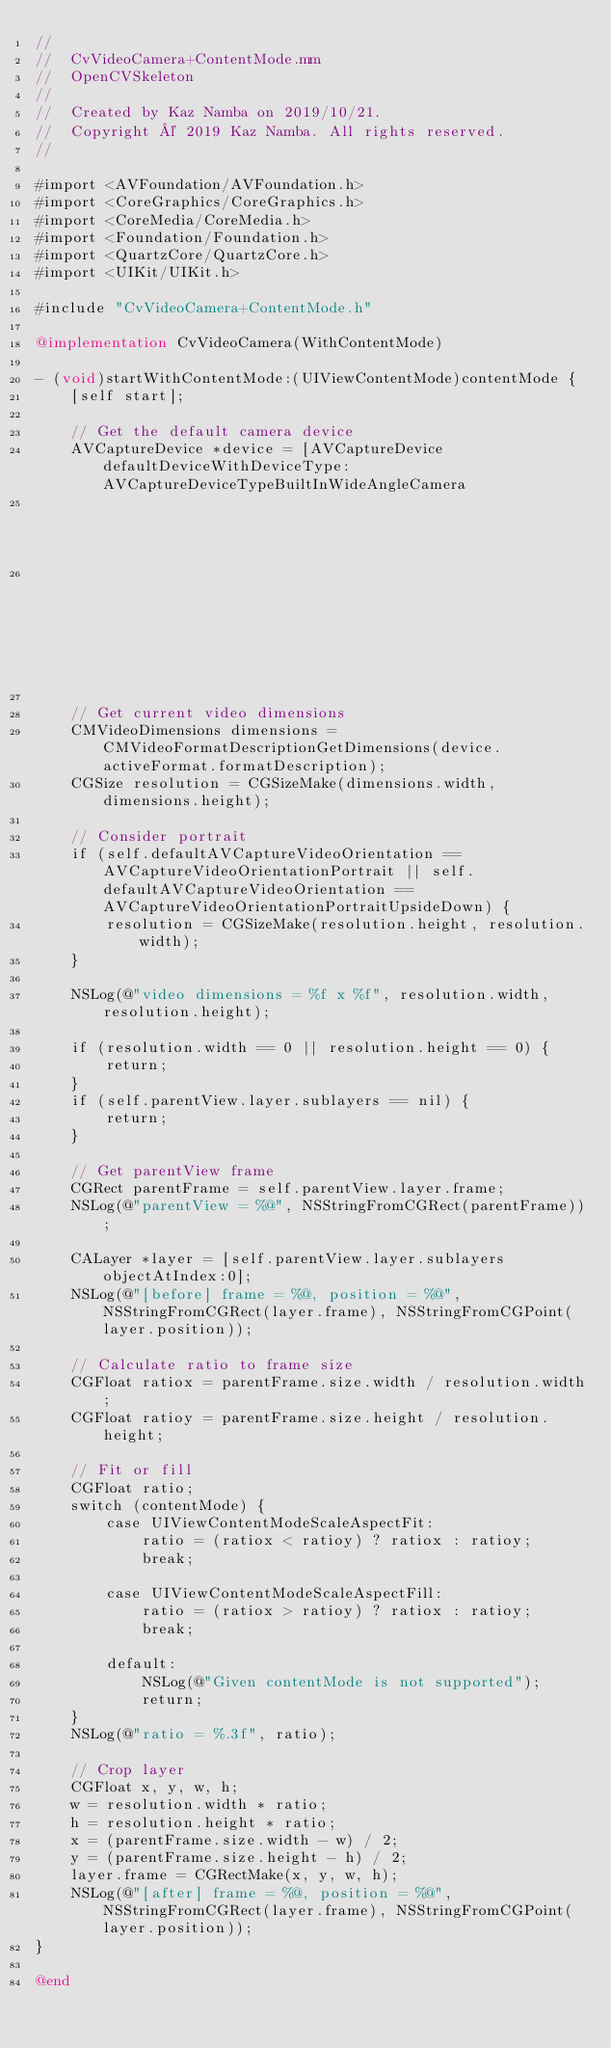<code> <loc_0><loc_0><loc_500><loc_500><_ObjectiveC_>//
//  CvVideoCamera+ContentMode.mm
//  OpenCVSkeleton
//
//  Created by Kaz Namba on 2019/10/21.
//  Copyright © 2019 Kaz Namba. All rights reserved.
//

#import <AVFoundation/AVFoundation.h>
#import <CoreGraphics/CoreGraphics.h>
#import <CoreMedia/CoreMedia.h>
#import <Foundation/Foundation.h>
#import <QuartzCore/QuartzCore.h>
#import <UIKit/UIKit.h>

#include "CvVideoCamera+ContentMode.h"

@implementation CvVideoCamera(WithContentMode)

- (void)startWithContentMode:(UIViewContentMode)contentMode {
    [self start];

    // Get the default camera device
    AVCaptureDevice *device = [AVCaptureDevice defaultDeviceWithDeviceType:AVCaptureDeviceTypeBuiltInWideAngleCamera
                                                                 mediaType:AVMediaTypeVideo
                                                                  position:self.defaultAVCaptureDevicePosition];

    // Get current video dimensions
    CMVideoDimensions dimensions = CMVideoFormatDescriptionGetDimensions(device.activeFormat.formatDescription);
    CGSize resolution = CGSizeMake(dimensions.width, dimensions.height);
    
    // Consider portrait
    if (self.defaultAVCaptureVideoOrientation == AVCaptureVideoOrientationPortrait || self.defaultAVCaptureVideoOrientation == AVCaptureVideoOrientationPortraitUpsideDown) {
        resolution = CGSizeMake(resolution.height, resolution.width);
    }
    
    NSLog(@"video dimensions = %f x %f", resolution.width, resolution.height);
    
    if (resolution.width == 0 || resolution.height == 0) {
        return;
    }
    if (self.parentView.layer.sublayers == nil) {
        return;
    }
    
    // Get parentView frame
    CGRect parentFrame = self.parentView.layer.frame;
    NSLog(@"parentView = %@", NSStringFromCGRect(parentFrame));
    
    CALayer *layer = [self.parentView.layer.sublayers objectAtIndex:0];
    NSLog(@"[before] frame = %@, position = %@", NSStringFromCGRect(layer.frame), NSStringFromCGPoint(layer.position));
    
    // Calculate ratio to frame size
    CGFloat ratiox = parentFrame.size.width / resolution.width;
    CGFloat ratioy = parentFrame.size.height / resolution.height;

    // Fit or fill
    CGFloat ratio;
    switch (contentMode) {
        case UIViewContentModeScaleAspectFit:
            ratio = (ratiox < ratioy) ? ratiox : ratioy;
            break;

        case UIViewContentModeScaleAspectFill:
            ratio = (ratiox > ratioy) ? ratiox : ratioy;
            break;

        default:
            NSLog(@"Given contentMode is not supported");
            return;
    }
    NSLog(@"ratio = %.3f", ratio);

    // Crop layer
    CGFloat x, y, w, h;
    w = resolution.width * ratio;
    h = resolution.height * ratio;
    x = (parentFrame.size.width - w) / 2;
    y = (parentFrame.size.height - h) / 2;
    layer.frame = CGRectMake(x, y, w, h);
    NSLog(@"[after] frame = %@, position = %@", NSStringFromCGRect(layer.frame), NSStringFromCGPoint(layer.position));
}

@end
</code> 